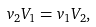Convert formula to latex. <formula><loc_0><loc_0><loc_500><loc_500>v _ { 2 } V _ { 1 } = v _ { 1 } V _ { 2 } ,</formula> 